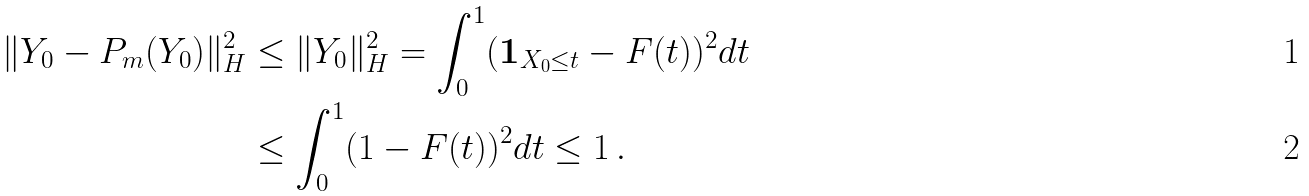Convert formula to latex. <formula><loc_0><loc_0><loc_500><loc_500>\| Y _ { 0 } - P _ { m } ( Y _ { 0 } ) \| _ { H } ^ { 2 } & \leq \| Y _ { 0 } \| _ { H } ^ { 2 } = \int _ { 0 } ^ { 1 } ( { \mathbf 1 } _ { X _ { 0 } \leq t } - F ( t ) ) ^ { 2 } d t \\ & \leq \int _ { 0 } ^ { 1 } ( 1 - F ( t ) ) ^ { 2 } d t \leq 1 \, .</formula> 